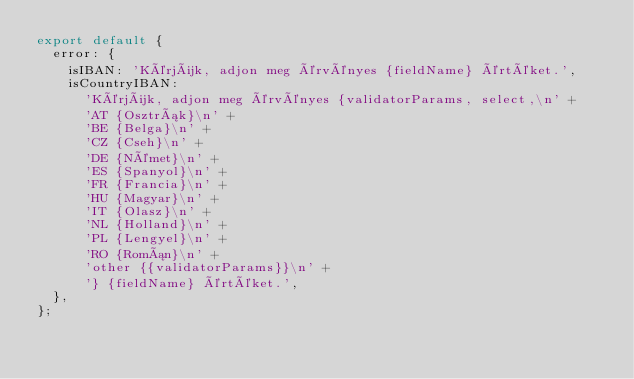<code> <loc_0><loc_0><loc_500><loc_500><_JavaScript_>export default {
  error: {
    isIBAN: 'Kérjük, adjon meg érvényes {fieldName} értéket.',
    isCountryIBAN:
      'Kérjük, adjon meg érvényes {validatorParams, select,\n' +
      'AT {Osztrák}\n' +
      'BE {Belga}\n' +
      'CZ {Cseh}\n' +
      'DE {Német}\n' +
      'ES {Spanyol}\n' +
      'FR {Francia}\n' +
      'HU {Magyar}\n' +
      'IT {Olasz}\n' +
      'NL {Holland}\n' +
      'PL {Lengyel}\n' +
      'RO {Román}\n' +
      'other {{validatorParams}}\n' +
      '} {fieldName} értéket.',
  },
};
</code> 